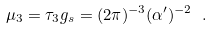Convert formula to latex. <formula><loc_0><loc_0><loc_500><loc_500>\mu _ { 3 } = \tau _ { 3 } g _ { s } = ( 2 \pi ) ^ { - 3 } ( \alpha ^ { \prime } ) ^ { - 2 } \ .</formula> 